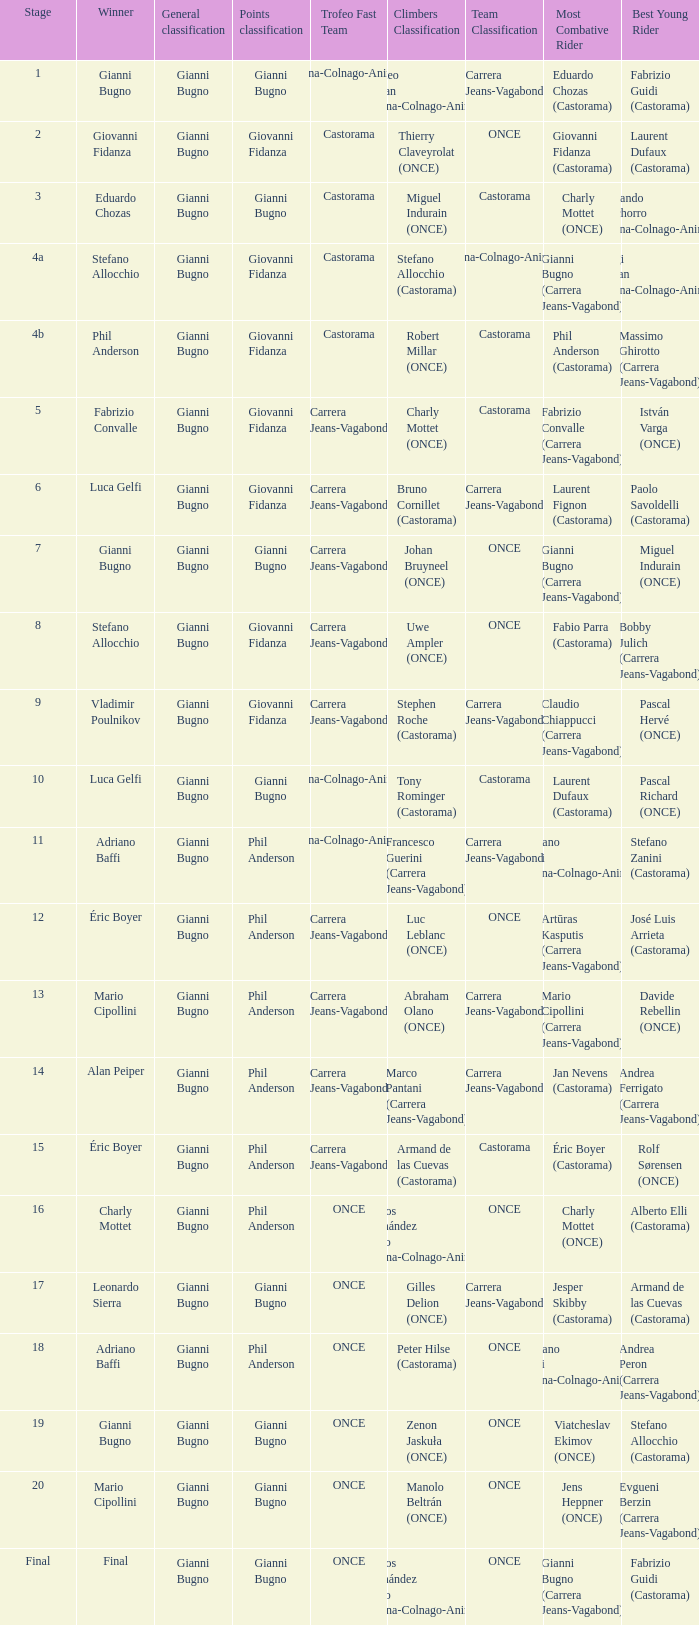Who is the trofeo fast team in stage 10? Diana-Colnago-Animex. 